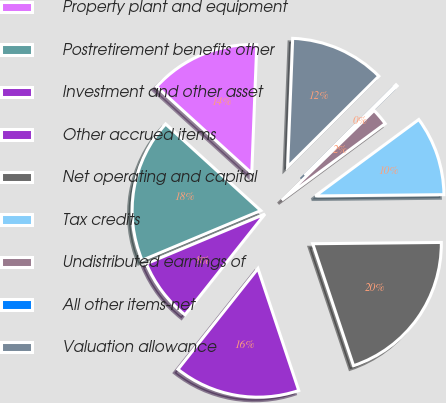<chart> <loc_0><loc_0><loc_500><loc_500><pie_chart><fcel>Property plant and equipment<fcel>Postretirement benefits other<fcel>Investment and other asset<fcel>Other accrued items<fcel>Net operating and capital<fcel>Tax credits<fcel>Undistributed earnings of<fcel>All other items-net<fcel>Valuation allowance<nl><fcel>13.87%<fcel>18.07%<fcel>8.01%<fcel>15.82%<fcel>20.02%<fcel>9.97%<fcel>2.14%<fcel>0.19%<fcel>11.92%<nl></chart> 